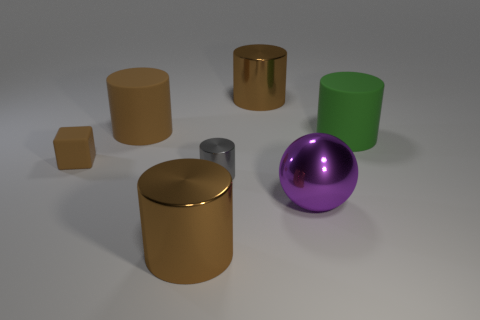Subtract all red blocks. How many brown cylinders are left? 3 Subtract all green cylinders. How many cylinders are left? 4 Subtract all big brown rubber cylinders. How many cylinders are left? 4 Add 3 small brown rubber things. How many objects exist? 10 Subtract all yellow cylinders. Subtract all cyan spheres. How many cylinders are left? 5 Subtract all spheres. How many objects are left? 6 Subtract 0 blue balls. How many objects are left? 7 Subtract all brown matte cylinders. Subtract all yellow metallic things. How many objects are left? 6 Add 4 large purple things. How many large purple things are left? 5 Add 6 purple balls. How many purple balls exist? 7 